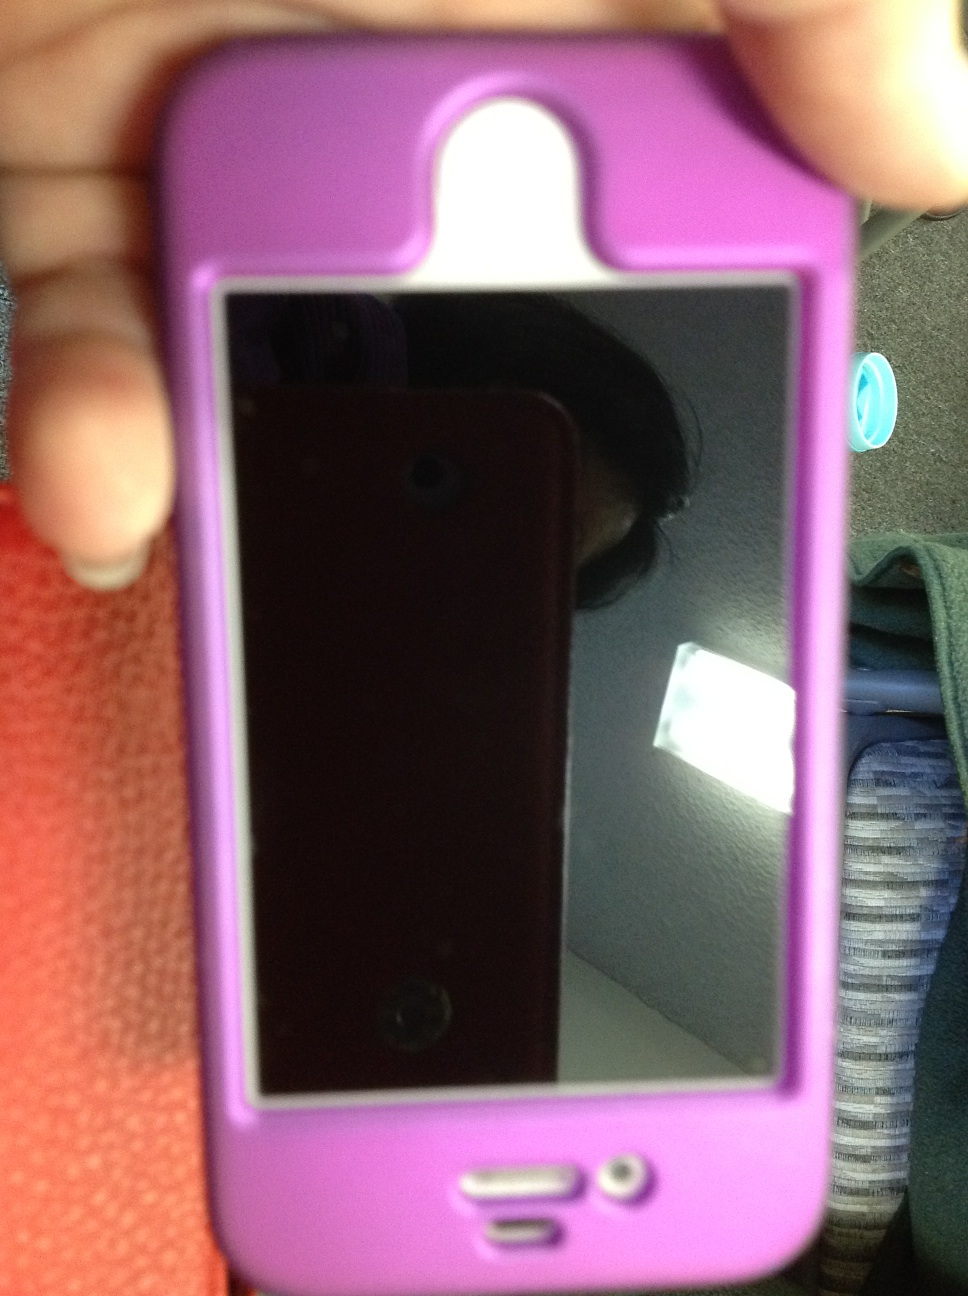Can you describe the condition of this phone? The phone appears to be in good condition. The screen is clean with no visible scratches, and the protective case looks intact and well-maintained. However, there might be minor signs of usage. What are the advantages of using a case like this one? Using a protective case like this one offers several advantages. Firstly, it helps shield the phone from drops and impacts, reducing the risk of screen cracks or body damage. Secondly, it can provide additional grip, making it less likely for the phone to slip out of your hand. Furthermore, cases often have raised edges to protect the screen and camera lens from scratches when placed on flat surfaces. Lastly, a case can add a personal touch to the phone's appearance, reflecting the user's style or preferences. What other features can a phone case have? Phone cases can come with various additional features depending on the design and intended use. Some cases offer built-in stands for hands-free media viewing, others have card slots or pockets to hold ID cards and cash. Certain cases also provide water resistance or waterproof capabilities to protect the phone from accidental spills or brief submersion. Additionally, there are cases with extra battery packs for extended battery life, ones with integrated magnets for easy mounting, and even military-grade options designed to withstand extreme conditions and drops. 